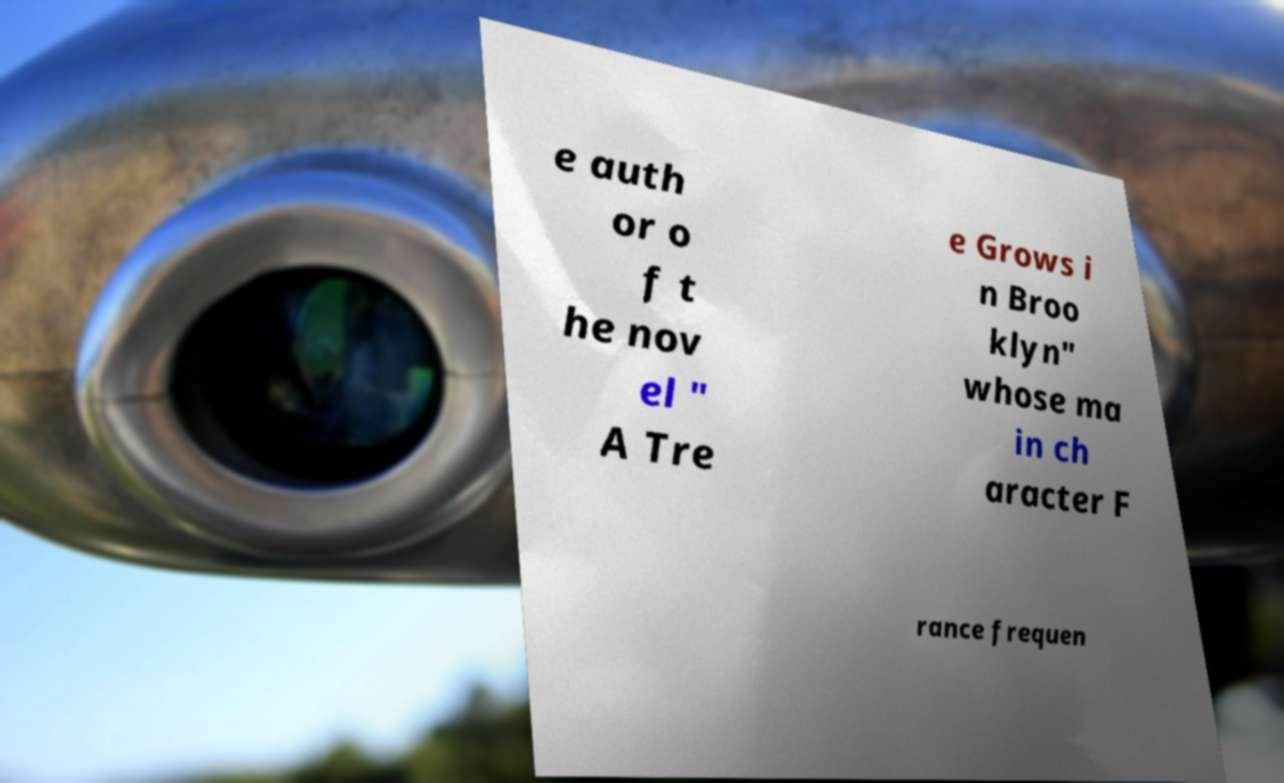Can you accurately transcribe the text from the provided image for me? e auth or o f t he nov el " A Tre e Grows i n Broo klyn" whose ma in ch aracter F rance frequen 